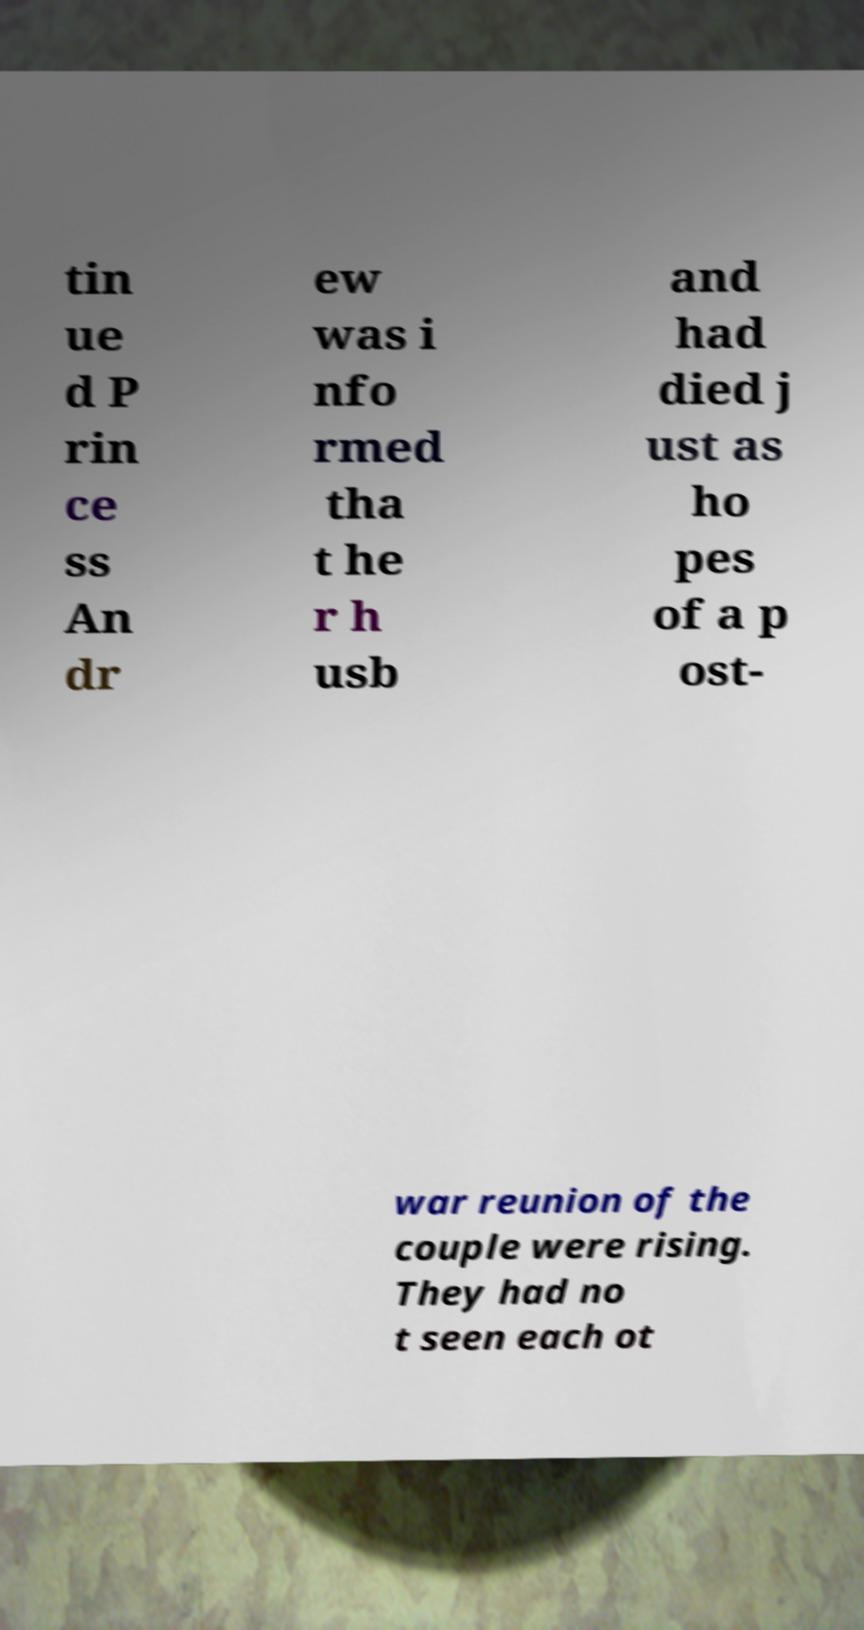Can you accurately transcribe the text from the provided image for me? tin ue d P rin ce ss An dr ew was i nfo rmed tha t he r h usb and had died j ust as ho pes of a p ost- war reunion of the couple were rising. They had no t seen each ot 